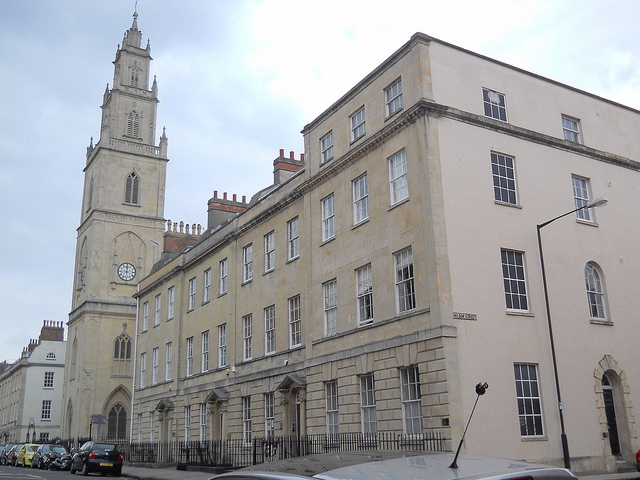What color are the chimney pieces on the top of the long rectangular house? The chimney pieces on top of the long rectangular house are red. This detail highlights the traditional architectural style commonly seen in such buildings and adds a distinct touch of color to the otherwise neutral-toned structure. 